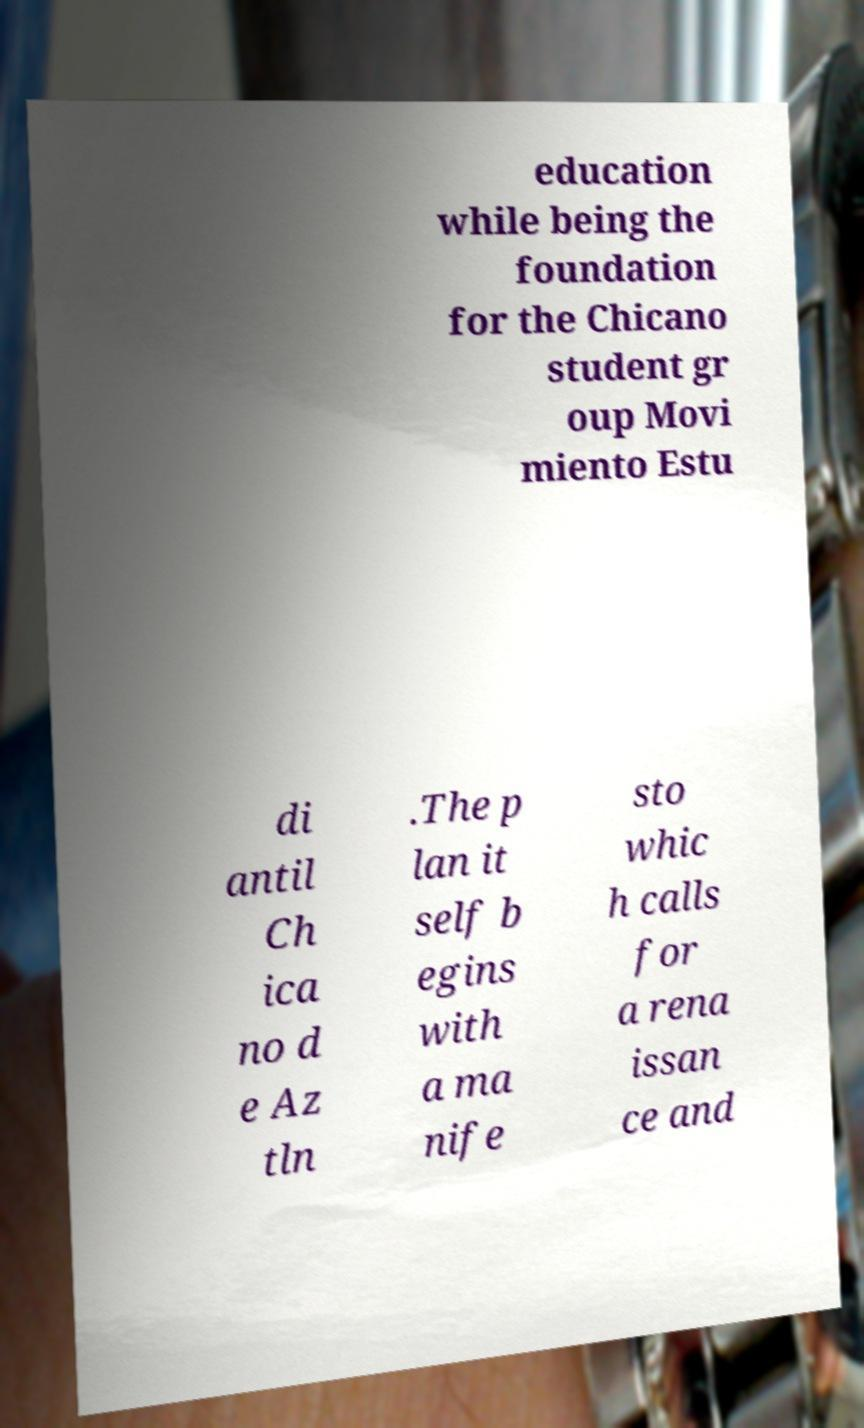Please read and relay the text visible in this image. What does it say? education while being the foundation for the Chicano student gr oup Movi miento Estu di antil Ch ica no d e Az tln .The p lan it self b egins with a ma nife sto whic h calls for a rena issan ce and 